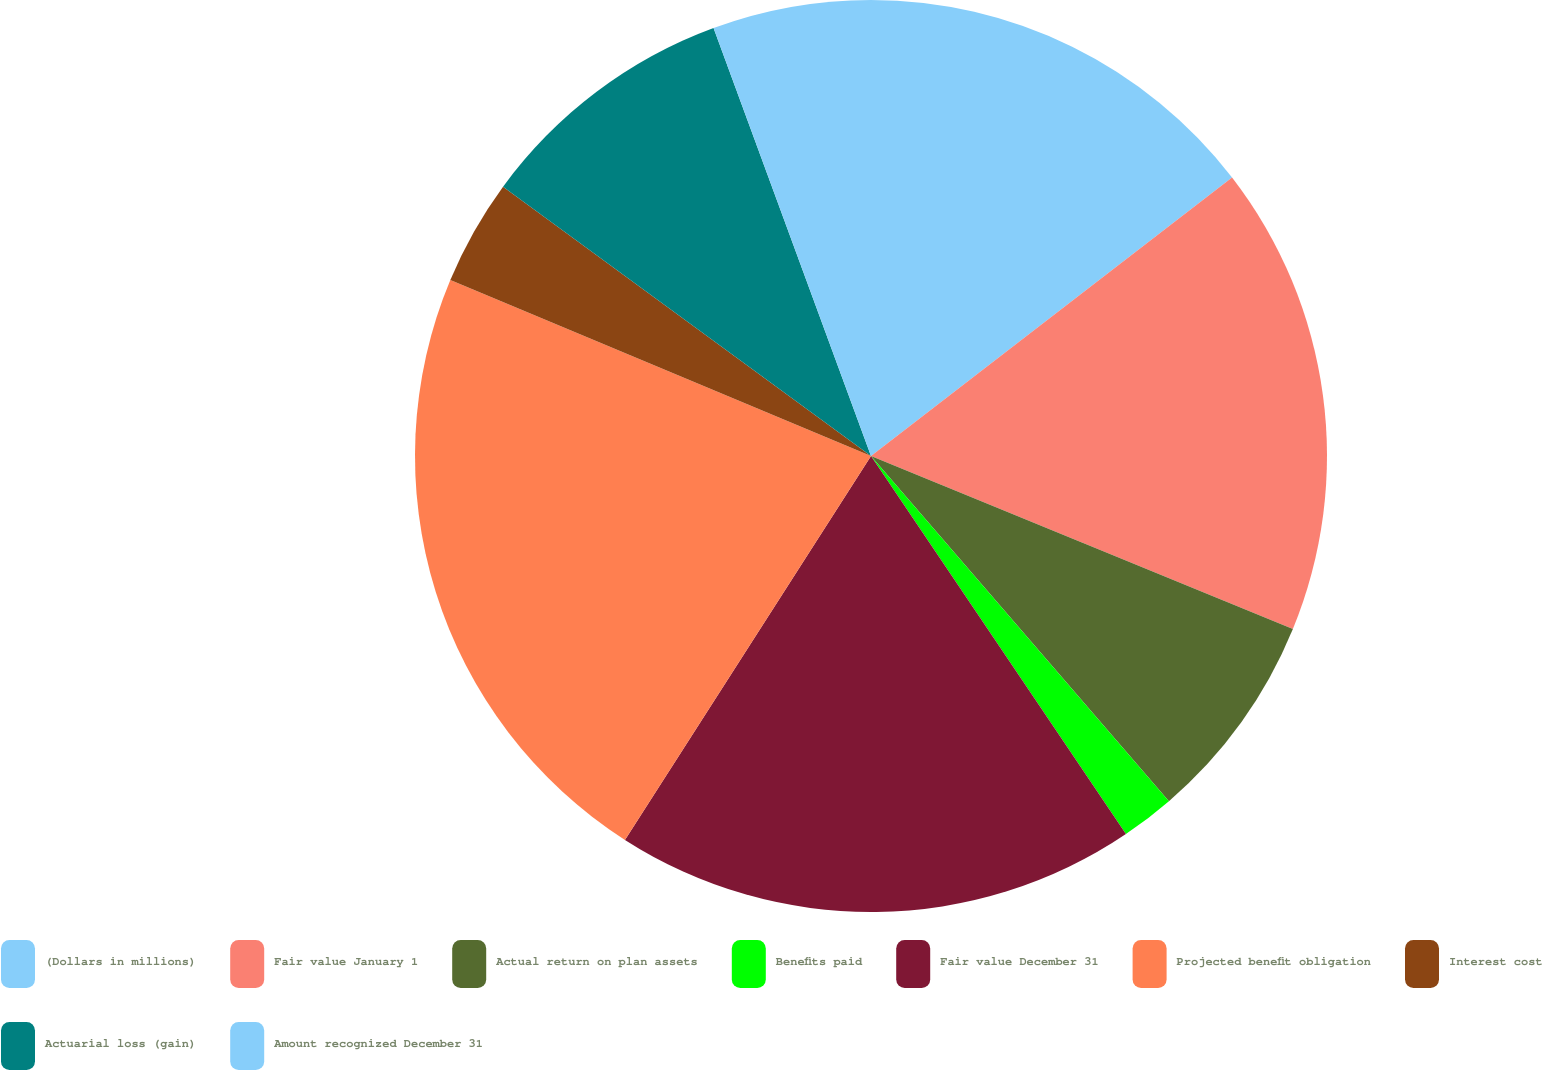Convert chart. <chart><loc_0><loc_0><loc_500><loc_500><pie_chart><fcel>(Dollars in millions)<fcel>Fair value January 1<fcel>Actual return on plan assets<fcel>Benefits paid<fcel>Fair value December 31<fcel>Projected benefit obligation<fcel>Interest cost<fcel>Actuarial loss (gain)<fcel>Amount recognized December 31<nl><fcel>14.54%<fcel>16.65%<fcel>7.47%<fcel>1.89%<fcel>18.51%<fcel>22.23%<fcel>3.75%<fcel>9.33%<fcel>5.61%<nl></chart> 